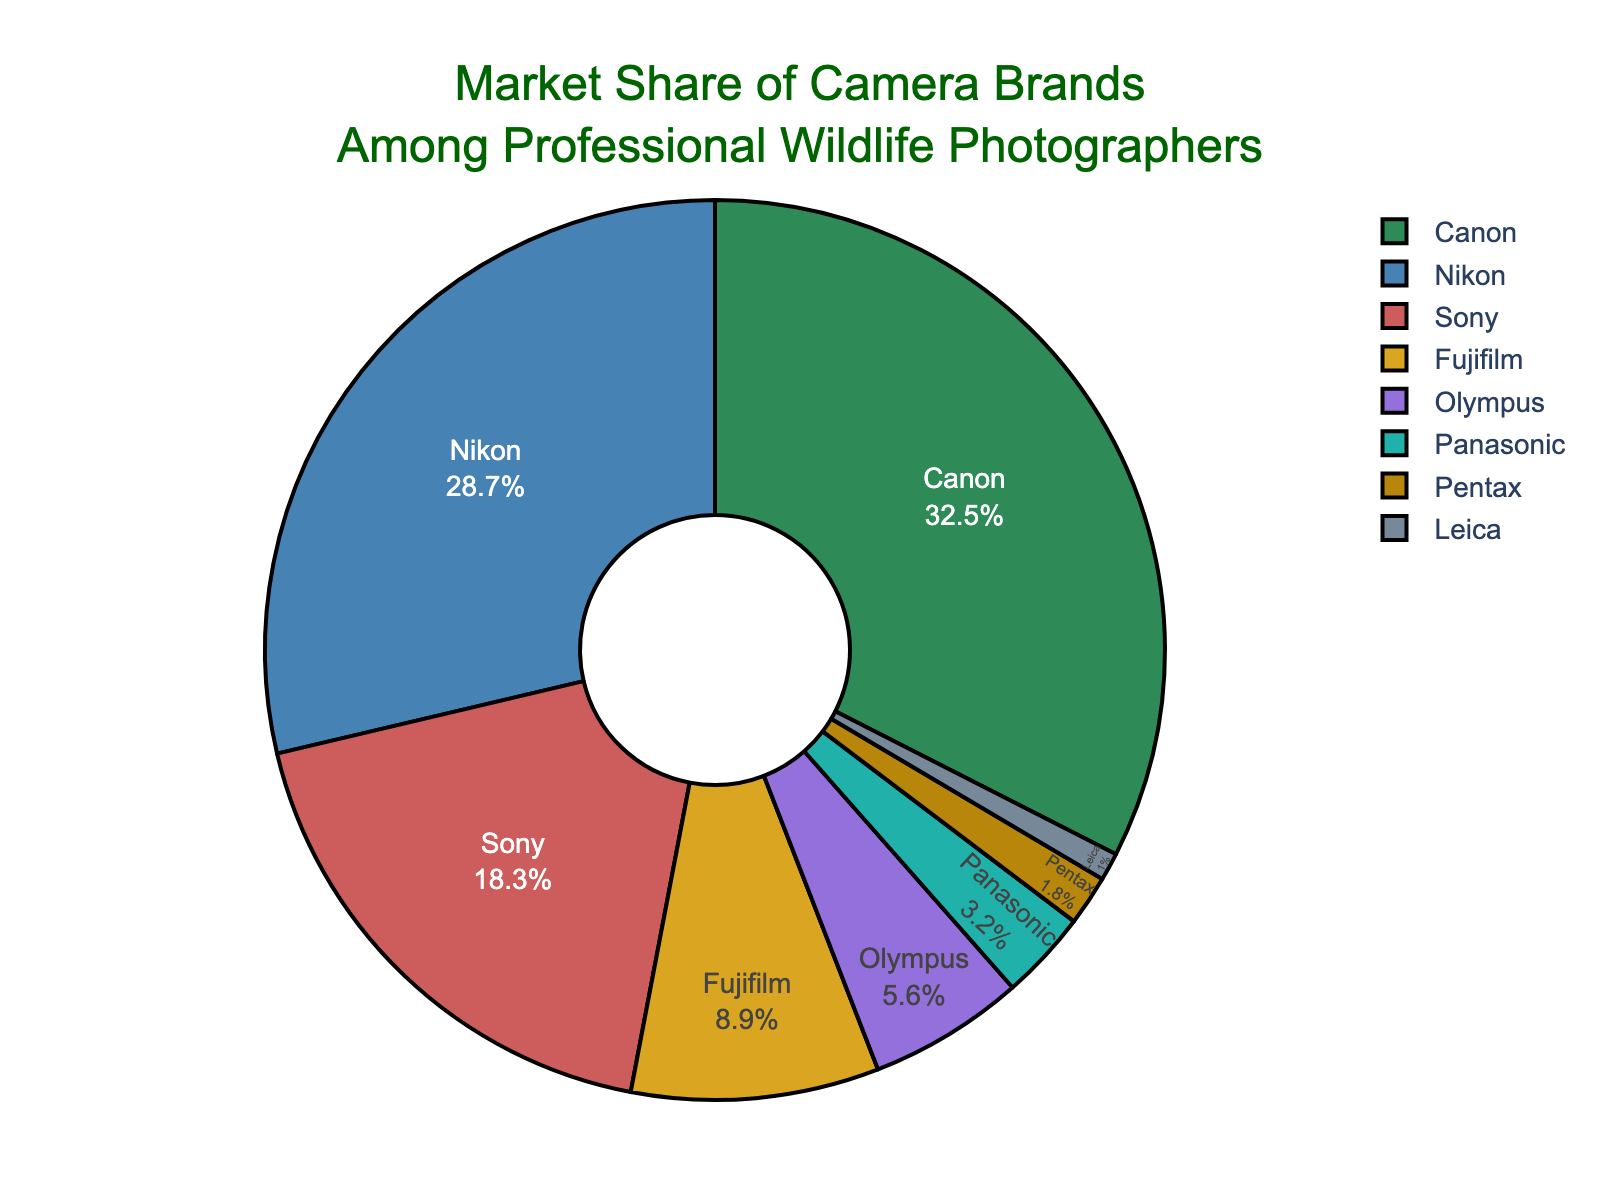What is the market share percentage of Nikon compared to Sony? Nikon has a market share of 28.7%, and Sony has 18.3%. Compare these two numbers by performing a simple subtraction: 28.7% - 18.3% = 10.4%. This means Nikon has a 10.4% higher market share than Sony.
Answer: 10.4% What is the sum of the market shares of Fujifilm, Olympus, Panasonic, Pentax, and Leica? To find the sum, add the market shares of these brands: Fujifilm (8.9%) + Olympus (5.6%) + Panasonic (3.2%) + Pentax (1.8%) + Leica (1.0%) = 20.5%.
Answer: 20.5% How much larger is Canon's market share than the combined market share of Fujifilm and Panasonic? Canon's market share is 32.5%. The combined market share of Fujifilm and Panasonic is 8.9% + 3.2% = 12.1%. Subtract the combined share from Canon's share: 32.5% - 12.1% = 20.4%. Canon's market share is 20.4% larger.
Answer: 20.4% Which brand has the smallest market share, and what is it? The smallest market share is for Leica, with a share of 1.0%.
Answer: Leica, 1.0% What percentage of the market share is held by Sony and Nikon together? Sony's market share is 18.3%, and Nikon's is 28.7%. Add these together for the total market share: 18.3% + 28.7% = 47.0%.
Answer: 47.0% What is the average market share of Canon, Nikon, and Sony? Calculate the average by summing the market shares and dividing by the number of brands: (Canon 32.5% + Nikon 28.7% + Sony 18.3%)/3 = 26.5%.
Answer: 26.5% Which brands have a market share larger than 10% and who has the highest market share among them? Canon (32.5%) and Nikon (28.7%) have market shares larger than 10%. Canon has the highest market share among them, which is 32.5%.
Answer: Canon, 32.5% Which brand has a market share of slightly less than 20% and what is its exact percentage and color in the chart? Sony has a market share of 18.3%, which is slightly less than 20%. In the chart, Sony is represented by a red color.
Answer: Sony, 18.3%, red What is the total market share of all brands combined? To find the total market share, sum the market shares of all brands: 32.5% (Canon) + 28.7% (Nikon) + 18.3% (Sony) + 8.9% (Fujifilm) + 5.6% (Olympus) + 3.2% (Panasonic) + 1.8% (Pentax) + 1.0% (Leica) = 100%.
Answer: 100% Which two brands, when combined, have a market share closest to 50%, and what is their combined market share? The combined market share of Nikon (28.7%) and Sony (18.3%) is 28.7% + 18.3% = 47.0%, which is closest to 50%.
Answer: Nikon and Sony, 47.0% 